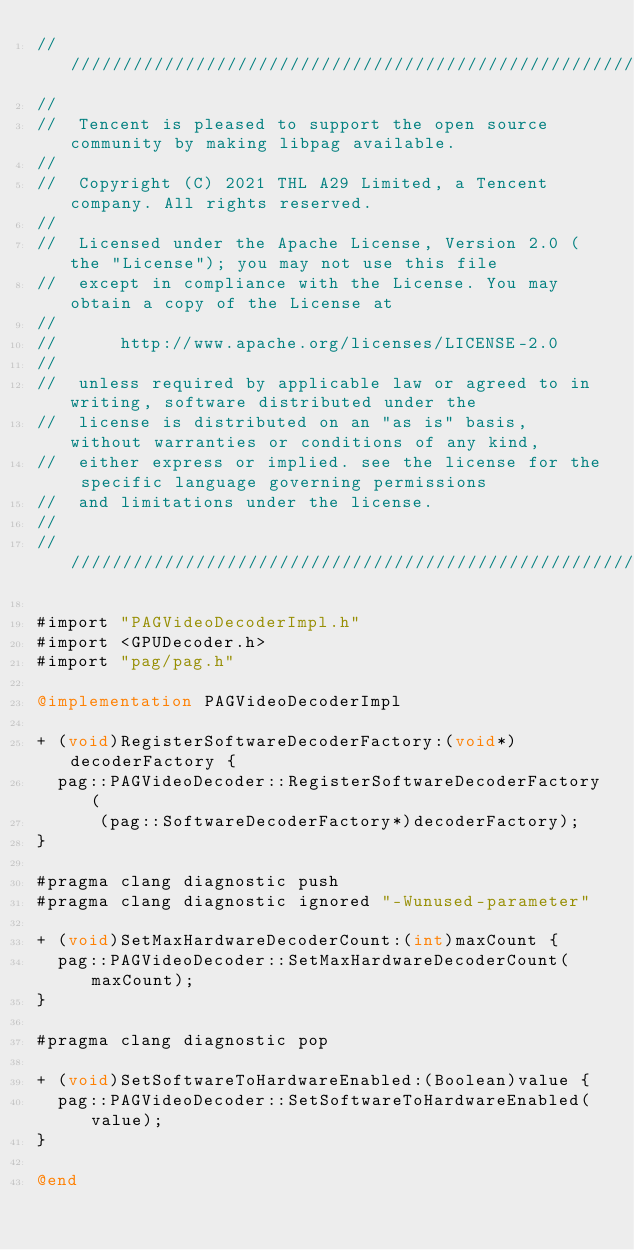Convert code to text. <code><loc_0><loc_0><loc_500><loc_500><_ObjectiveC_>/////////////////////////////////////////////////////////////////////////////////////////////////
//
//  Tencent is pleased to support the open source community by making libpag available.
//
//  Copyright (C) 2021 THL A29 Limited, a Tencent company. All rights reserved.
//
//  Licensed under the Apache License, Version 2.0 (the "License"); you may not use this file
//  except in compliance with the License. You may obtain a copy of the License at
//
//      http://www.apache.org/licenses/LICENSE-2.0
//
//  unless required by applicable law or agreed to in writing, software distributed under the
//  license is distributed on an "as is" basis, without warranties or conditions of any kind,
//  either express or implied. see the license for the specific language governing permissions
//  and limitations under the license.
//
/////////////////////////////////////////////////////////////////////////////////////////////////

#import "PAGVideoDecoderImpl.h"
#import <GPUDecoder.h>
#import "pag/pag.h"

@implementation PAGVideoDecoderImpl

+ (void)RegisterSoftwareDecoderFactory:(void*)decoderFactory {
  pag::PAGVideoDecoder::RegisterSoftwareDecoderFactory(
      (pag::SoftwareDecoderFactory*)decoderFactory);
}

#pragma clang diagnostic push
#pragma clang diagnostic ignored "-Wunused-parameter"

+ (void)SetMaxHardwareDecoderCount:(int)maxCount {
  pag::PAGVideoDecoder::SetMaxHardwareDecoderCount(maxCount);
}

#pragma clang diagnostic pop

+ (void)SetSoftwareToHardwareEnabled:(Boolean)value {
  pag::PAGVideoDecoder::SetSoftwareToHardwareEnabled(value);
}

@end
</code> 